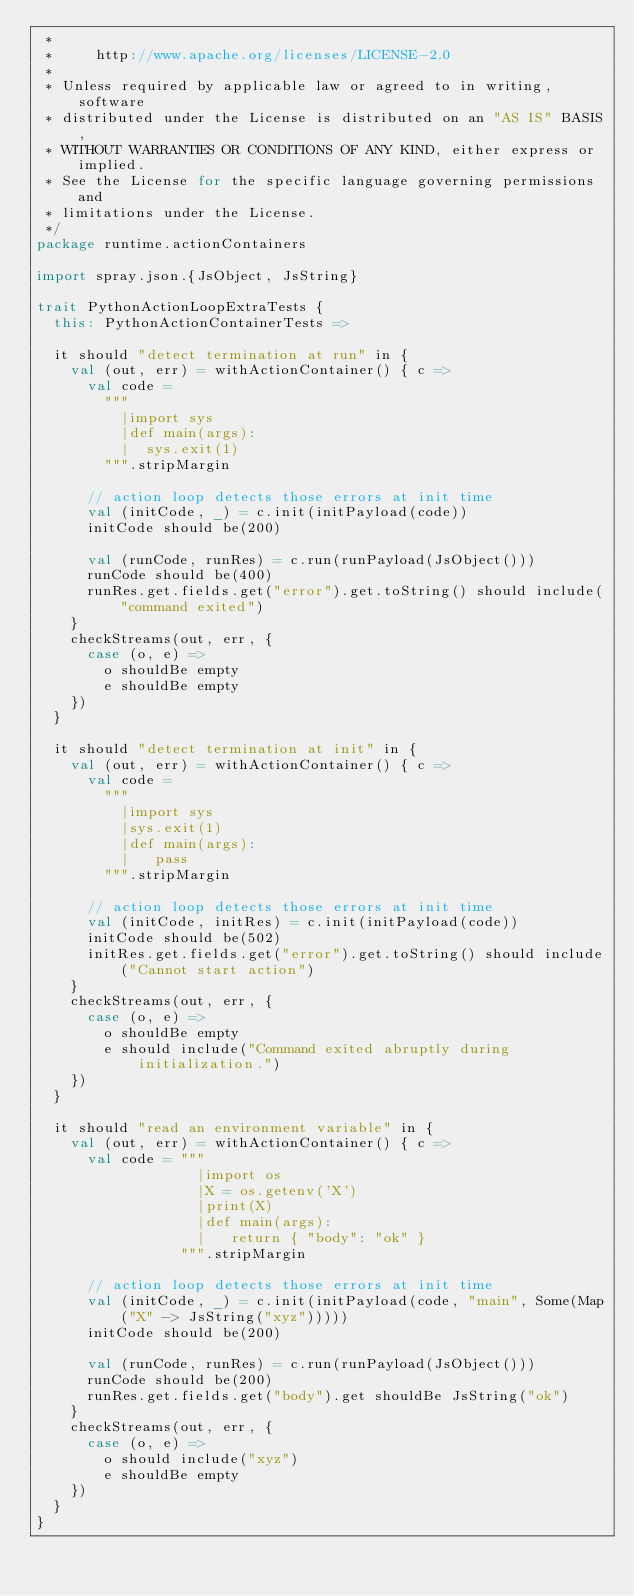Convert code to text. <code><loc_0><loc_0><loc_500><loc_500><_Scala_> *
 *     http://www.apache.org/licenses/LICENSE-2.0
 *
 * Unless required by applicable law or agreed to in writing, software
 * distributed under the License is distributed on an "AS IS" BASIS,
 * WITHOUT WARRANTIES OR CONDITIONS OF ANY KIND, either express or implied.
 * See the License for the specific language governing permissions and
 * limitations under the License.
 */
package runtime.actionContainers

import spray.json.{JsObject, JsString}

trait PythonActionLoopExtraTests {
  this: PythonActionContainerTests =>

  it should "detect termination at run" in {
    val (out, err) = withActionContainer() { c =>
      val code =
        """
          |import sys
          |def main(args):
          |  sys.exit(1)
        """.stripMargin

      // action loop detects those errors at init time
      val (initCode, _) = c.init(initPayload(code))
      initCode should be(200)

      val (runCode, runRes) = c.run(runPayload(JsObject()))
      runCode should be(400)
      runRes.get.fields.get("error").get.toString() should include("command exited")
    }
    checkStreams(out, err, {
      case (o, e) =>
        o shouldBe empty
        e shouldBe empty
    })
  }

  it should "detect termination at init" in {
    val (out, err) = withActionContainer() { c =>
      val code =
        """
          |import sys
          |sys.exit(1)
          |def main(args):
          |   pass
        """.stripMargin

      // action loop detects those errors at init time
      val (initCode, initRes) = c.init(initPayload(code))
      initCode should be(502)
      initRes.get.fields.get("error").get.toString() should include("Cannot start action")
    }
    checkStreams(out, err, {
      case (o, e) =>
        o shouldBe empty
        e should include("Command exited abruptly during initialization.")
    })
  }

  it should "read an environment variable" in {
    val (out, err) = withActionContainer() { c =>
      val code = """
                   |import os
                   |X = os.getenv('X')
                   |print(X)
                   |def main(args):
                   |   return { "body": "ok" }
                 """.stripMargin

      // action loop detects those errors at init time
      val (initCode, _) = c.init(initPayload(code, "main", Some(Map("X" -> JsString("xyz")))))
      initCode should be(200)

      val (runCode, runRes) = c.run(runPayload(JsObject()))
      runCode should be(200)
      runRes.get.fields.get("body").get shouldBe JsString("ok")
    }
    checkStreams(out, err, {
      case (o, e) =>
        o should include("xyz")
        e shouldBe empty
    })
  }
}
</code> 